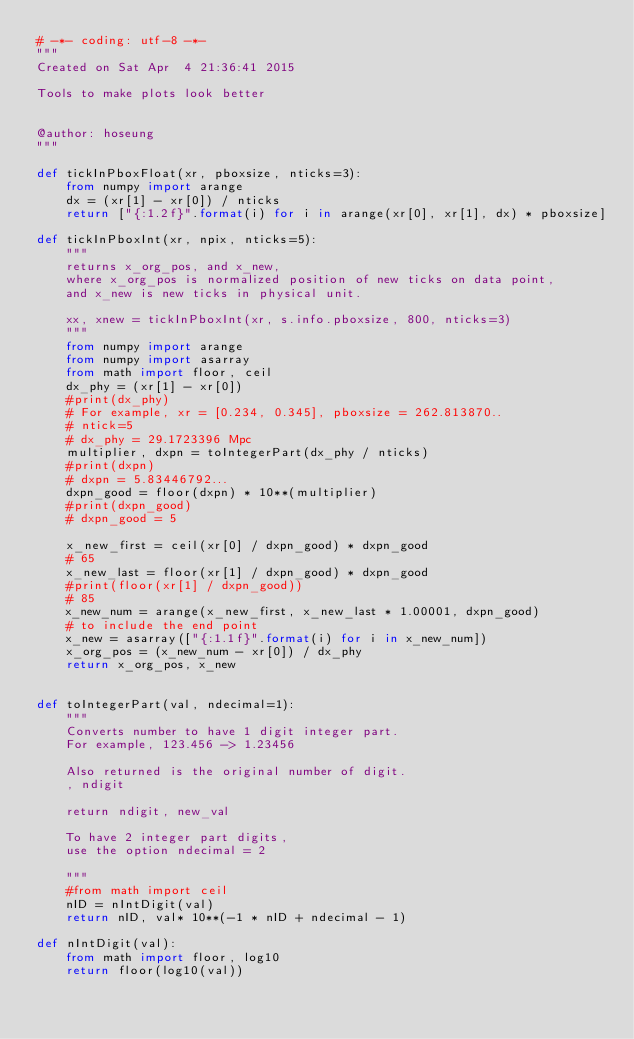<code> <loc_0><loc_0><loc_500><loc_500><_Python_># -*- coding: utf-8 -*-
"""
Created on Sat Apr  4 21:36:41 2015

Tools to make plots look better


@author: hoseung
"""

def tickInPboxFloat(xr, pboxsize, nticks=3):
    from numpy import arange
    dx = (xr[1] - xr[0]) / nticks
    return ["{:1.2f}".format(i) for i in arange(xr[0], xr[1], dx) * pboxsize]

def tickInPboxInt(xr, npix, nticks=5):
    """
    returns x_org_pos, and x_new,
    where x_org_pos is normalized position of new ticks on data point,
    and x_new is new ticks in physical unit.

    xx, xnew = tickInPboxInt(xr, s.info.pboxsize, 800, nticks=3)
    """
    from numpy import arange
    from numpy import asarray
    from math import floor, ceil
    dx_phy = (xr[1] - xr[0])
    #print(dx_phy)
    # For example, xr = [0.234, 0.345], pboxsize = 262.813870..
    # ntick=5
    # dx_phy = 29.1723396 Mpc
    multiplier, dxpn = toIntegerPart(dx_phy / nticks)
    #print(dxpn)
    # dxpn = 5.83446792...
    dxpn_good = floor(dxpn) * 10**(multiplier)
    #print(dxpn_good)
    # dxpn_good = 5

    x_new_first = ceil(xr[0] / dxpn_good) * dxpn_good
    # 65
    x_new_last = floor(xr[1] / dxpn_good) * dxpn_good
    #print(floor(xr[1] / dxpn_good))
    # 85
    x_new_num = arange(x_new_first, x_new_last * 1.00001, dxpn_good)
    # to include the end point
    x_new = asarray(["{:1.1f}".format(i) for i in x_new_num])
    x_org_pos = (x_new_num - xr[0]) / dx_phy
    return x_org_pos, x_new


def toIntegerPart(val, ndecimal=1):
    """
    Converts number to have 1 digit integer part.
    For example, 123.456 -> 1.23456

    Also returned is the original number of digit.
    , ndigit

    return ndigit, new_val

    To have 2 integer part digits,
    use the option ndecimal = 2

    """
    #from math import ceil
    nID = nIntDigit(val)
    return nID, val* 10**(-1 * nID + ndecimal - 1)

def nIntDigit(val):
    from math import floor, log10
    return floor(log10(val))</code> 